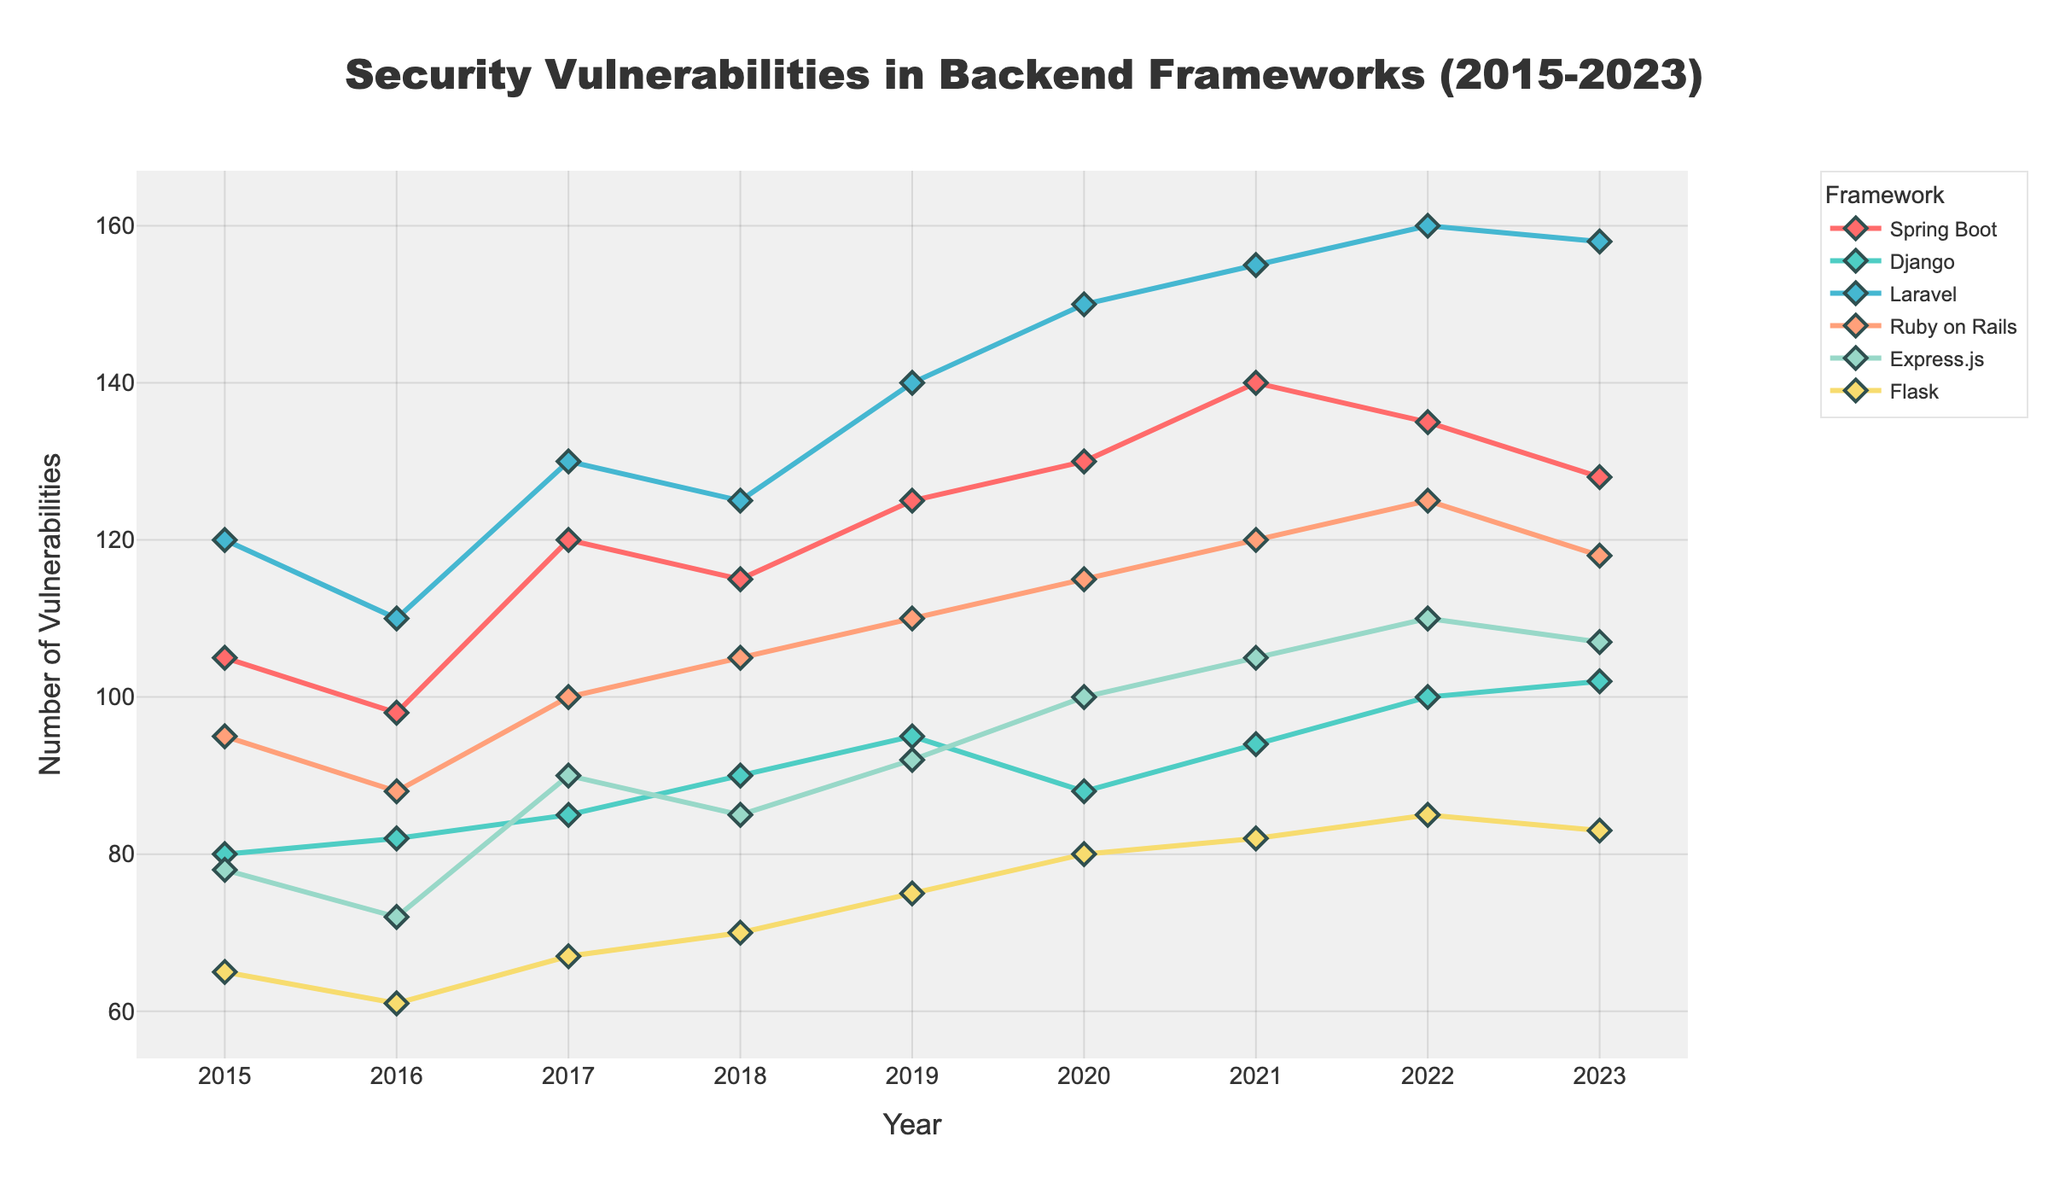How many frameworks are being compared in the figure? The figure shows lines for Spring Boot, Django, Laravel, Ruby on Rails, Express.js, and Flask. You can count the number of unique lines or refer to the legend of the plot.
Answer: 6 Which backend framework reported the highest number of security vulnerabilities in 2021? Look at the data points for the year 2021 and identify which framework has the highest value.
Answer: Laravel What is the trend of security vulnerabilities for Spring Boot from 2015 to 2023? Observe the line corresponding to Spring Boot from 2015 to 2023. The number of vulnerabilities generally increased, peaking in 2021, and then slightly decreased by 2023.
Answer: Increasing trend, peak in 2021, slight decrease by 2023 Which framework had the least security vulnerabilities in 2015? Look at the data points for 2015 and find which one has the lowest value.
Answer: Flask On average, how many vulnerabilities were reported in Express.js from 2017 to 2020? Sum the vulnerabilities for Express.js from 2017 to 2020 and divide by the number of years (4). The values are 90, 85, 92, and 100. Sum is 367, and the average is 367/4.
Answer: 91.75 Between 2018 and 2020, which framework showed a decrease in the number of vulnerabilities? Compare the data points from 2018 to 2020 for each framework. The one(s) where the 2020 value is less than the 2018 value indicate a decrease.
Answer: Flask and Django Between 2015 and 2017, which framework had the most significant increase in security vulnerabilities? For each framework, calculate the difference between their vulnerabilities in 2017 and 2015, and identify which one has the largest increase.
Answer: Laravel How many security vulnerabilities were reported in total for Django from 2019 to 2023? Add the values for Django from 2019 to 2023. The values are 95, 88, 94, 100, and 102. Sum is 479.
Answer: 479 Which frameworks' lines intersect on the plot, indicating equal vulnerabilities at any specific year? Look for points where lines intersect, closely examine the data, or use visual cues on the plot. If none intersect, state that.
Answer: None What can be inferred about the security vulnerability trend for Flask from 2015 to 2023? Observe the complete line for Flask. Flask shows a slight increase overall from 2015 to 2023 with some fluctuations.
Answer: Slight increase with fluctuations 